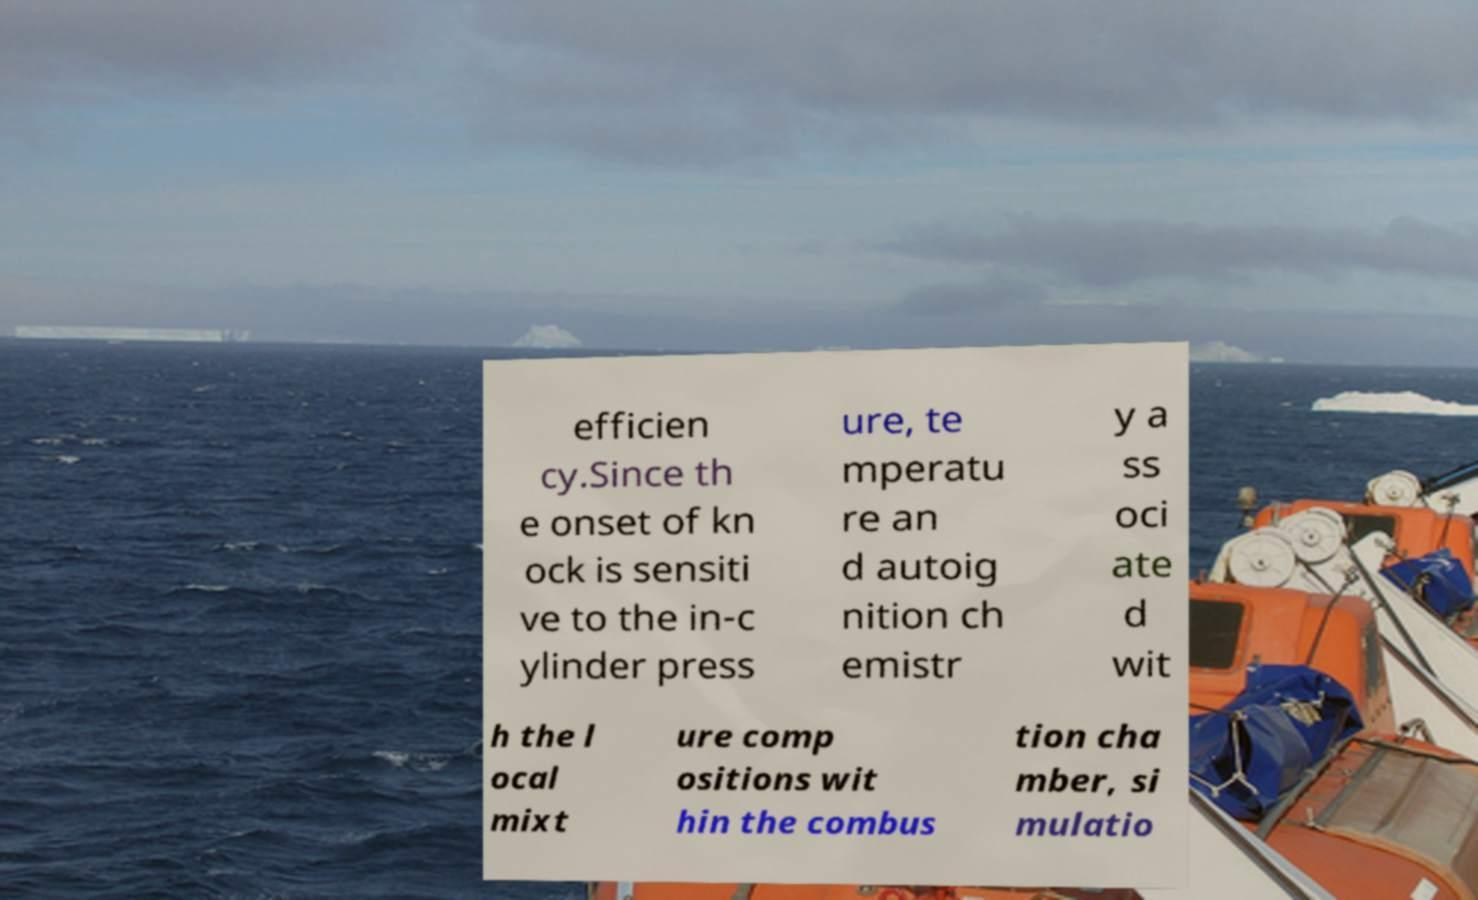Please read and relay the text visible in this image. What does it say? efficien cy.Since th e onset of kn ock is sensiti ve to the in-c ylinder press ure, te mperatu re an d autoig nition ch emistr y a ss oci ate d wit h the l ocal mixt ure comp ositions wit hin the combus tion cha mber, si mulatio 